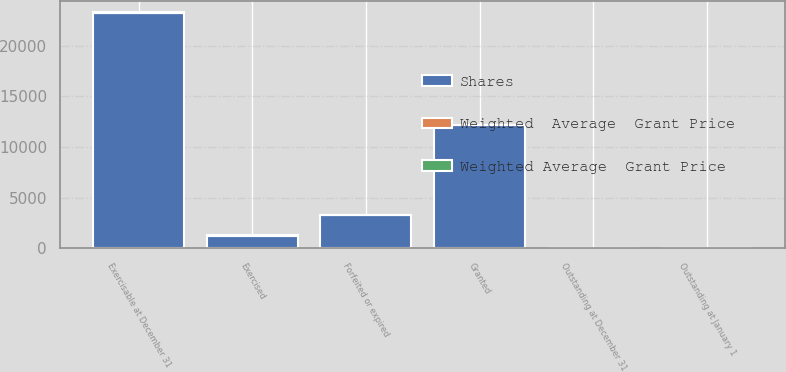<chart> <loc_0><loc_0><loc_500><loc_500><stacked_bar_chart><ecel><fcel>Outstanding at January 1<fcel>Granted<fcel>Exercised<fcel>Forfeited or expired<fcel>Outstanding at December 31<fcel>Exercisable at December 31<nl><fcel>Shares<fcel>24<fcel>12179<fcel>1271<fcel>3290<fcel>24<fcel>23248<nl><fcel>Weighted Average  Grant Price<fcel>22.2<fcel>14.36<fcel>6.29<fcel>23.33<fcel>20.41<fcel>26.76<nl><fcel>Weighted  Average  Grant Price<fcel>24.67<fcel>13.36<fcel>3.96<fcel>25.76<fcel>22.2<fcel>30.29<nl></chart> 